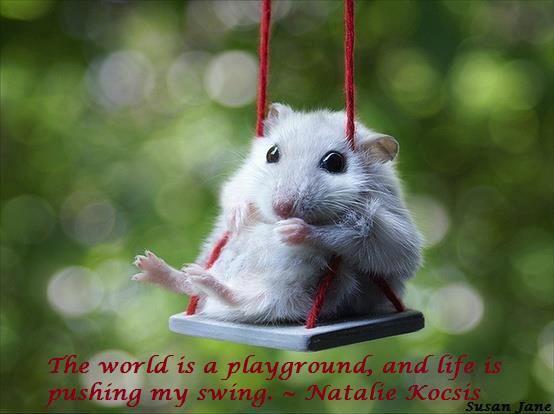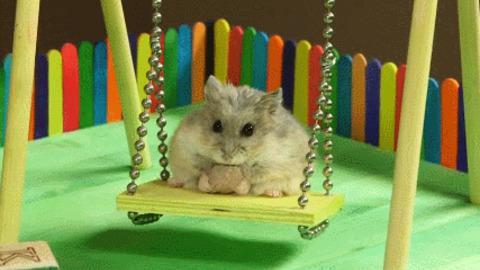The first image is the image on the left, the second image is the image on the right. Considering the images on both sides, is "Th e image on the left contains two hamsters." valid? Answer yes or no. No. The first image is the image on the left, the second image is the image on the right. Considering the images on both sides, is "Two hamsters are on swings." valid? Answer yes or no. Yes. 